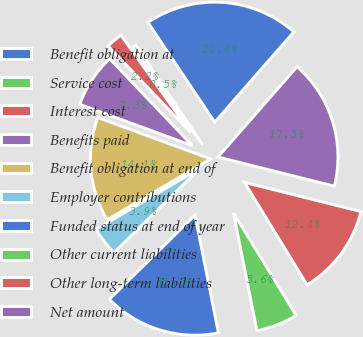<chart> <loc_0><loc_0><loc_500><loc_500><pie_chart><fcel>Benefit obligation at<fcel>Service cost<fcel>Interest cost<fcel>Benefits paid<fcel>Benefit obligation at end of<fcel>Employer contributions<fcel>Funded status at end of year<fcel>Other current liabilities<fcel>Other long-term liabilities<fcel>Net amount<nl><fcel>20.84%<fcel>0.51%<fcel>2.21%<fcel>7.29%<fcel>14.07%<fcel>3.9%<fcel>15.76%<fcel>5.6%<fcel>12.37%<fcel>17.45%<nl></chart> 